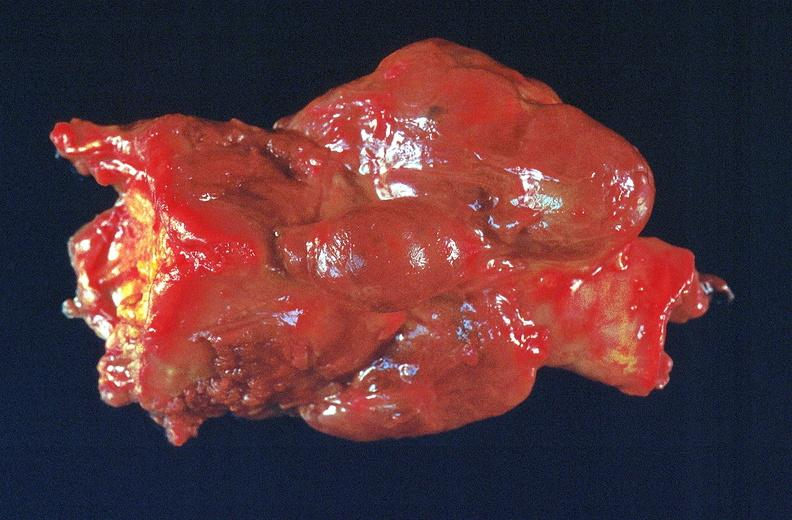what is present?
Answer the question using a single word or phrase. Endocrine 